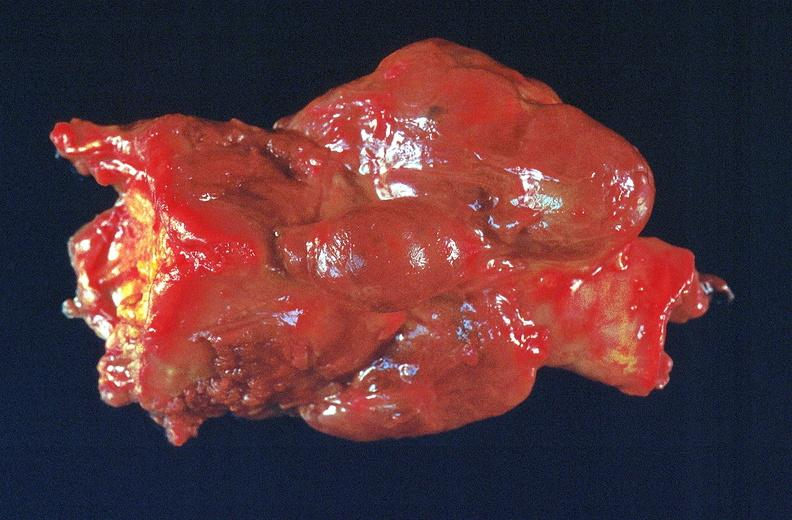what is present?
Answer the question using a single word or phrase. Endocrine 